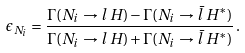Convert formula to latex. <formula><loc_0><loc_0><loc_500><loc_500>\epsilon _ { N _ { i } } = \frac { \Gamma ( N _ { i } \to l \, H ) - \Gamma ( N _ { i } \to \bar { l } \, H ^ { * } ) } { \Gamma ( N _ { i } \to l \, H ) + \Gamma ( N _ { i } \to \bar { l } \, H ^ { * } ) } \, .</formula> 